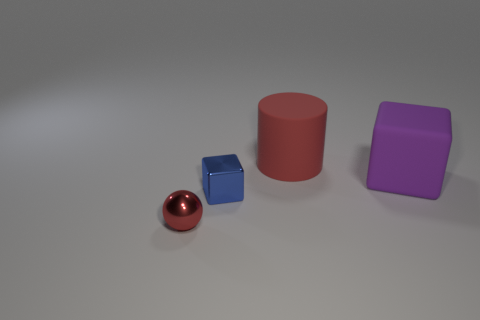Add 2 metal things. How many objects exist? 6 Subtract all spheres. How many objects are left? 3 Subtract 1 purple cubes. How many objects are left? 3 Subtract all big matte objects. Subtract all purple matte cubes. How many objects are left? 1 Add 3 large red things. How many large red things are left? 4 Add 4 blue metallic things. How many blue metallic things exist? 5 